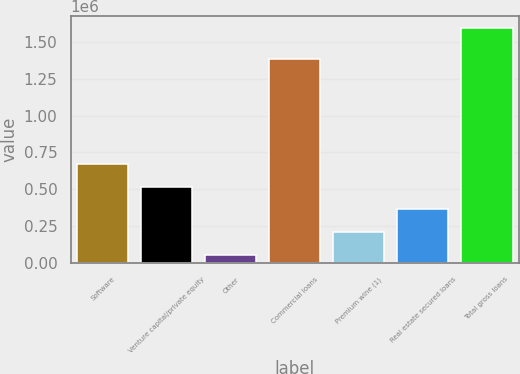<chart> <loc_0><loc_0><loc_500><loc_500><bar_chart><fcel>Software<fcel>Venture capital/private equity<fcel>Other<fcel>Commercial loans<fcel>Premium wine (1)<fcel>Real estate secured loans<fcel>Total gross loans<nl><fcel>671988<fcel>517893<fcel>55608<fcel>1.38486e+06<fcel>209703<fcel>363798<fcel>1.59656e+06<nl></chart> 